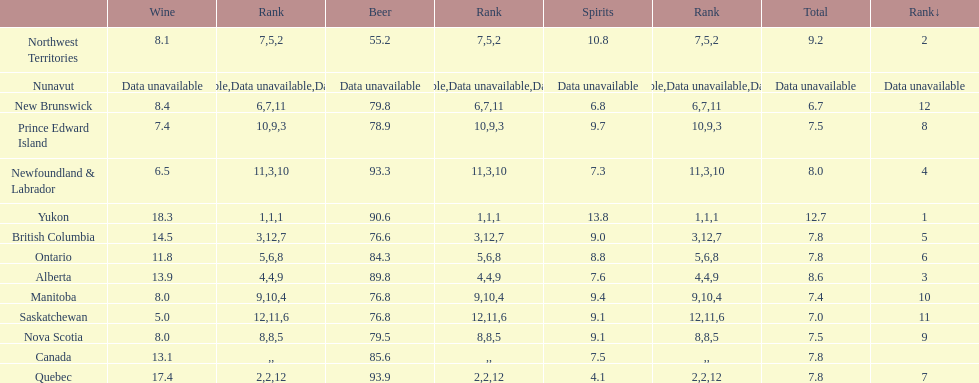Which province consumes the least amount of spirits? Quebec. 